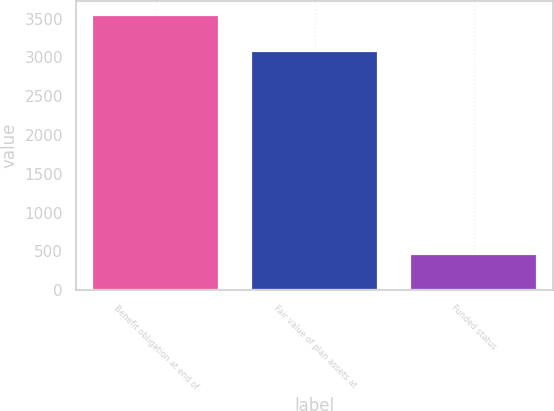Convert chart to OTSL. <chart><loc_0><loc_0><loc_500><loc_500><bar_chart><fcel>Benefit obligation at end of<fcel>Fair value of plan assets at<fcel>Funded status<nl><fcel>3546<fcel>3077<fcel>469<nl></chart> 